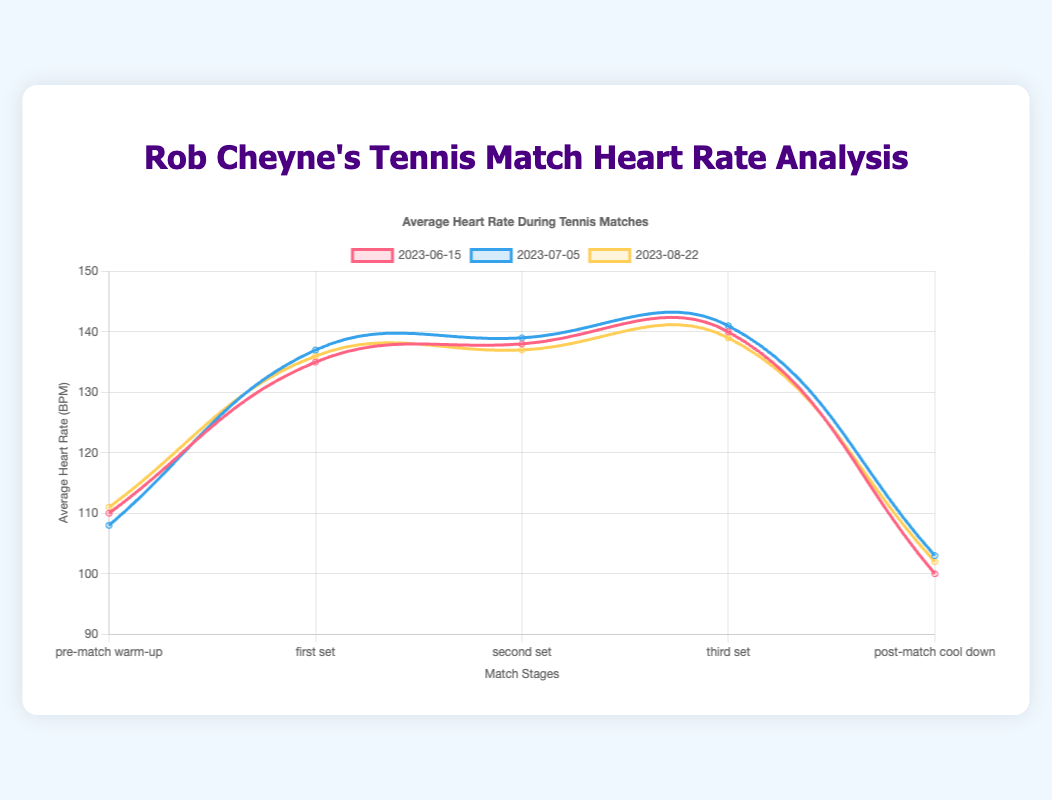What is the average heart rate of Rob Cheyne during the pre-match warm-up in the match on 2023-06-15? Look at the data point corresponding to the pre-match warm-up stage for the match on 2023-06-15.
Answer: 110 bpm How does Rob Cheyne's heart rate change from the first set to the third set on 2023-07-05? Compare the heart rates in the first set (137 bpm), second set (139 bpm), and third set (141 bpm). Notice the increase between these sets.
Answer: Increases What is the difference in Rob Cheyne's average heart rate between the second set and the post-match cool down on 2023-08-22? Subtract the heart rate in the post-match cool down (102 bpm) from that in the second set (137 bpm): 137 - 102 = 35 bpm.
Answer: 35 bpm During which match stage did Rob Cheyne have the highest heart rate on 2023-06-15? Look at all the data points for Rob Cheyne on 2023-06-15 and find the highest value. The highest heart rate is during the third set (140 bpm).
Answer: Third set Which match date has the lowest heart rate recorded for Rob Cheyne, and during which stage? Check all stages across all match dates for Rob Cheyne and find the lowest heart rate. It is 100 bpm during the post-match cool down on 2023-06-15.
Answer: 2023-06-15, post-match cool down Compare Rob Cheyne's average heart rate during the pre-match warm-up across all provided match dates. Is there a trend? Examine the pre-match warm-up heart rates (110 bpm, 108 bpm, 111 bpm) and see if there’s a rising or falling pattern. They are fairly consistent, with slight variation.
Answer: Fairly consistent Between the first and third set, who had the greatest increase in heart rate for any match? Compare the rise in heart rates from the first set to the third set for all matches. For Rob Cheyne on 2023-07-05, the increase was from 137 bpm to 141 bpm (an increase of 4 bpm).
Answer: Rob Cheyne on 2023-07-05 For Rob Cheyne during the post-match cool down stages, how does his heart rate trend over the three matches? Observe the post-match cool down heart rates (100 bpm, 103 bpm, 102 bpm) to identify any trend. They slightly increase overall, with a small drop in the last match.
Answer: Slightly increasing Which player's heart rate is consistently lower than 140 bpm during all match stages? Look at all players' heart rates during each stage and identify if anyone is consistently below 140 bpm. John Doe fits this criterion.
Answer: John Doe Which match had the smallest range of heart rates for Rob Cheyne? Calculate the range (max heart rate - min heart rate) for Rob Cheyne in each match. The smallest range is for the match on 2023-08-22 (139 bpm - 102 bpm = 37 bpm).
Answer: 2023-08-22 